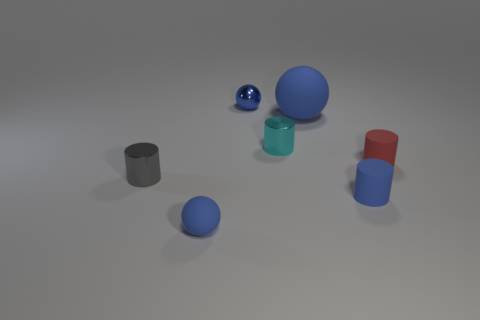What could be a possible real-world setting for these objects? Given the simplicity and cleanliness of the objects, they could be part of an educational setting for teaching geometry or physics, such as demonstrating shapes, volume, and the basics of light and shadow in a classroom or laboratory environment. 